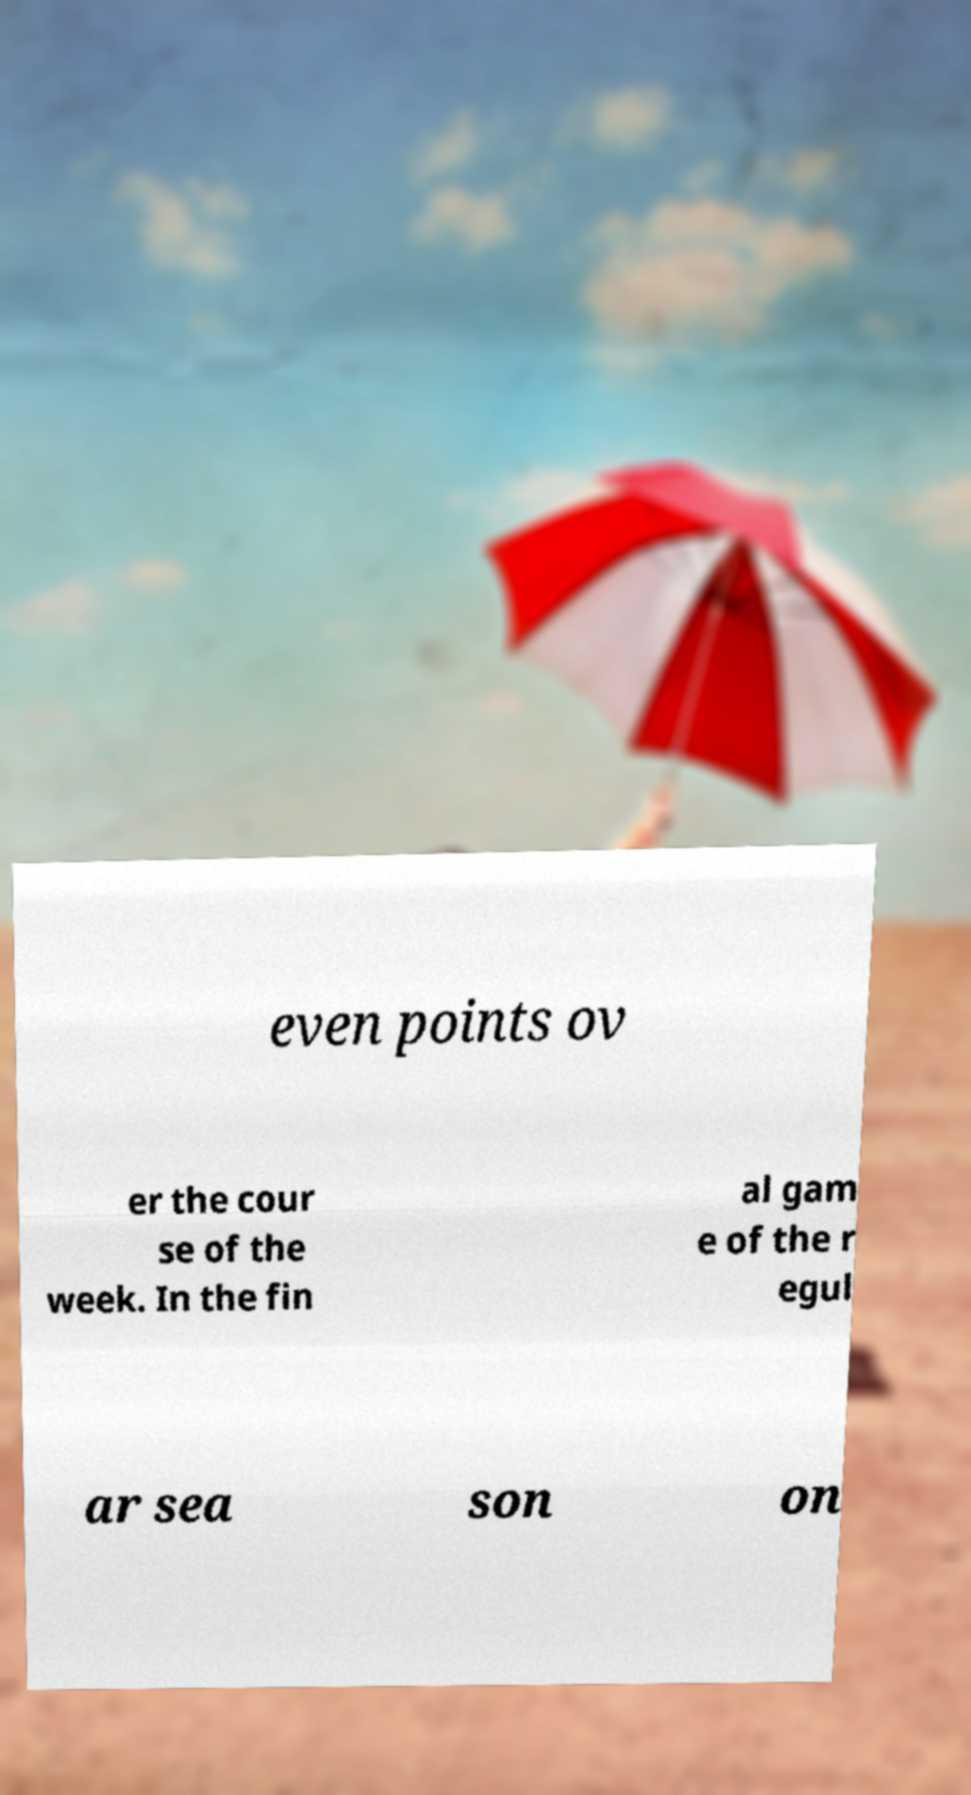What messages or text are displayed in this image? I need them in a readable, typed format. even points ov er the cour se of the week. In the fin al gam e of the r egul ar sea son on 